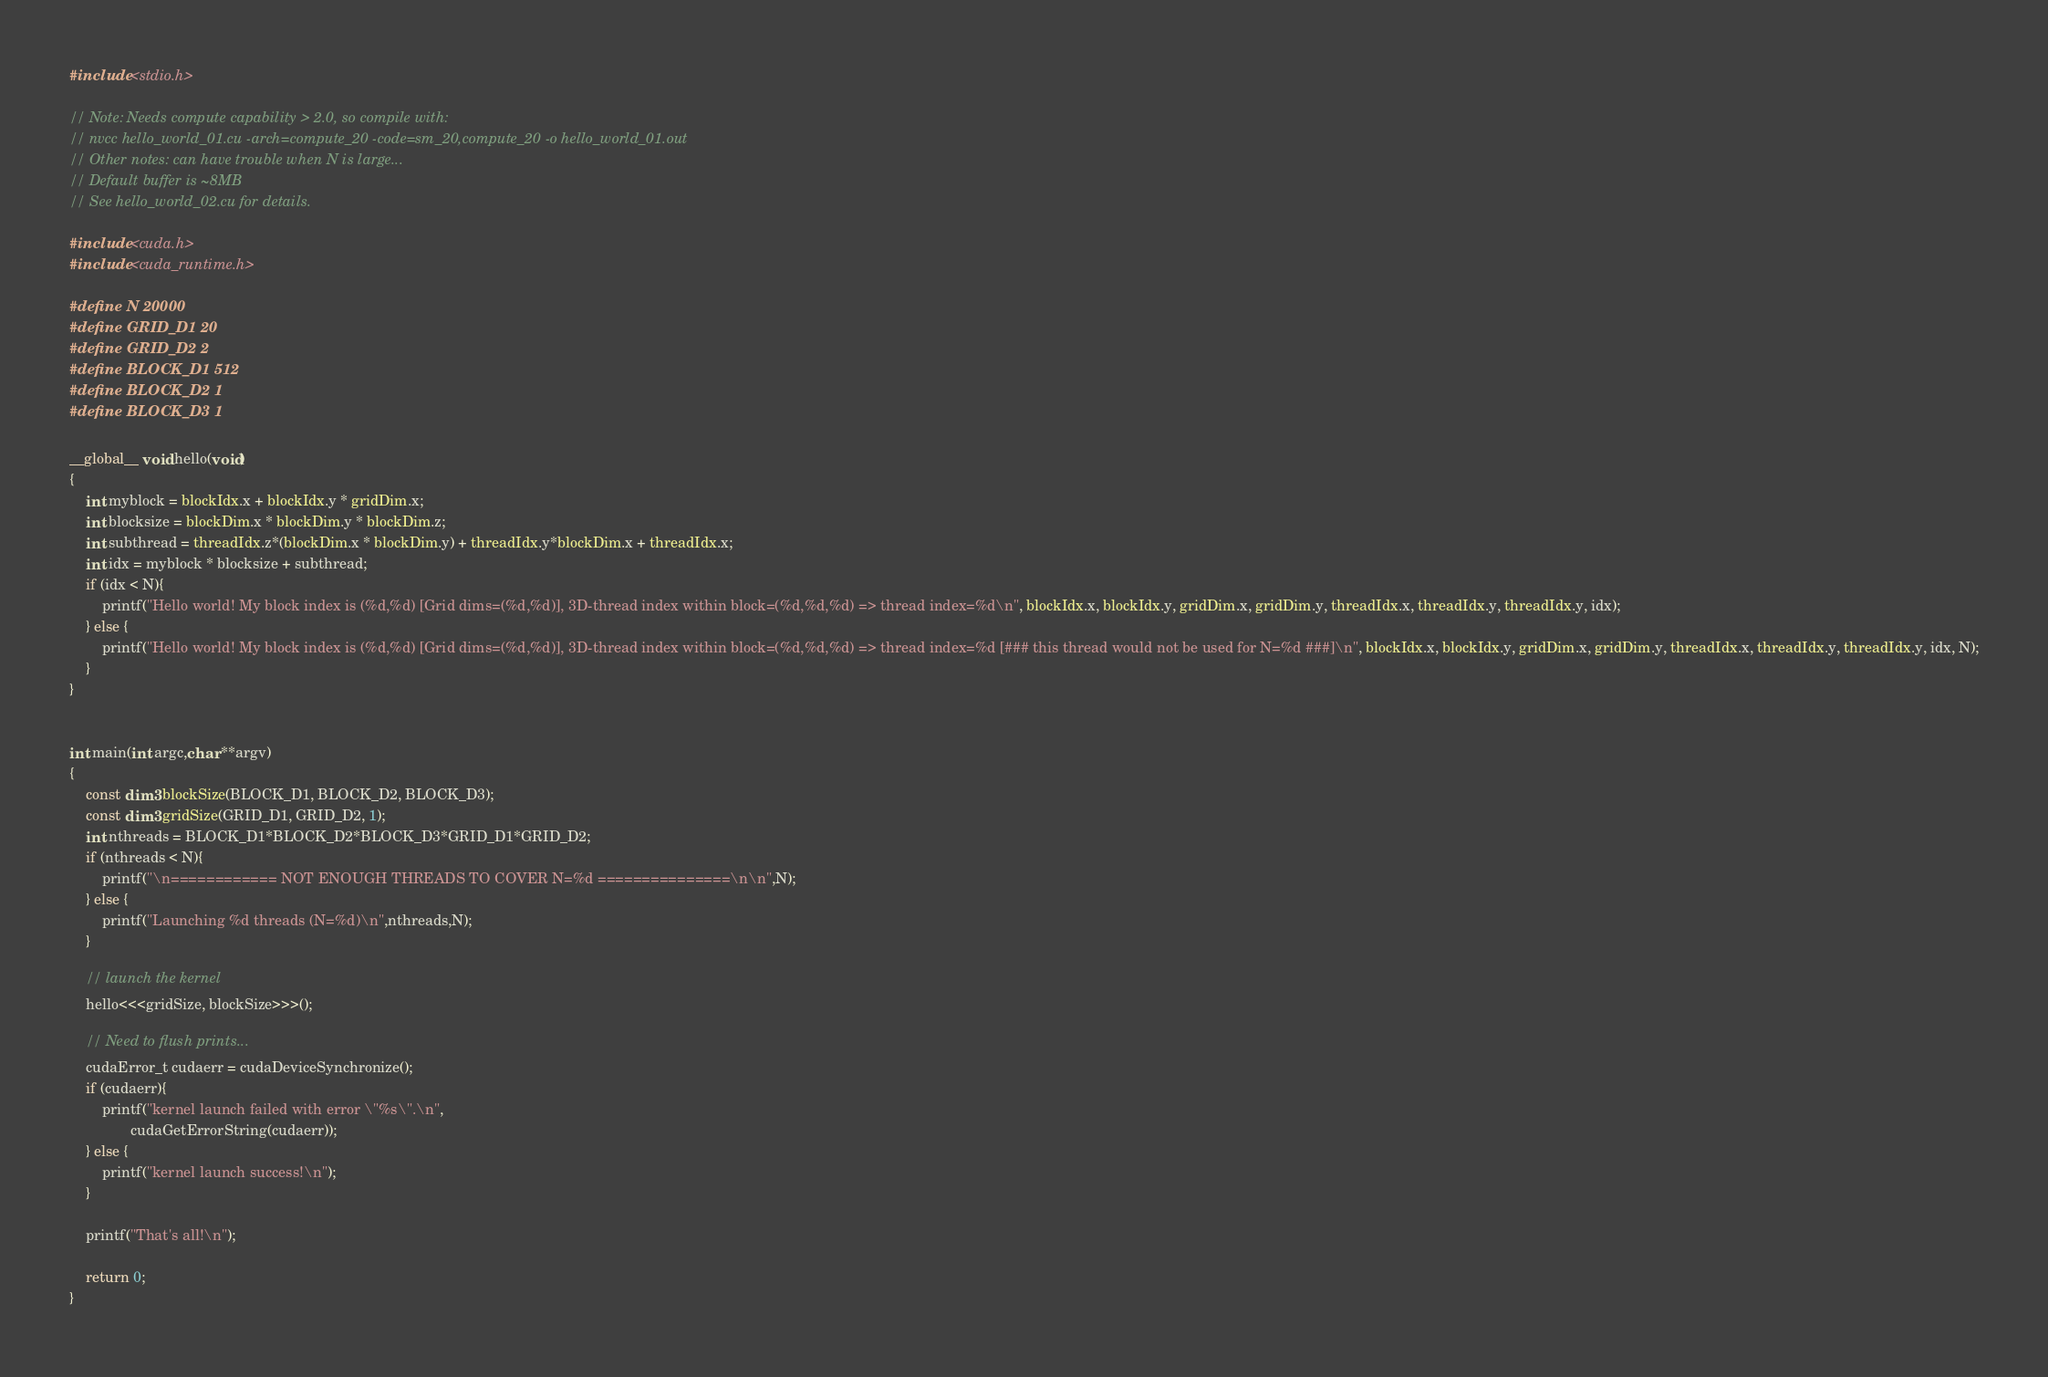Convert code to text. <code><loc_0><loc_0><loc_500><loc_500><_Cuda_>#include <stdio.h>

// Note: Needs compute capability > 2.0, so compile with:
// nvcc hello_world_01.cu -arch=compute_20 -code=sm_20,compute_20 -o hello_world_01.out
// Other notes: can have trouble when N is large...
// Default buffer is ~8MB
// See hello_world_02.cu for details.

#include <cuda.h>
#include <cuda_runtime.h>

#define N 20000
#define GRID_D1 20
#define GRID_D2 2
#define BLOCK_D1 512
#define BLOCK_D2 1
#define BLOCK_D3 1

__global__ void hello(void)
{
    int myblock = blockIdx.x + blockIdx.y * gridDim.x;
    int blocksize = blockDim.x * blockDim.y * blockDim.z;
    int subthread = threadIdx.z*(blockDim.x * blockDim.y) + threadIdx.y*blockDim.x + threadIdx.x;
    int idx = myblock * blocksize + subthread;
    if (idx < N){  
        printf("Hello world! My block index is (%d,%d) [Grid dims=(%d,%d)], 3D-thread index within block=(%d,%d,%d) => thread index=%d\n", blockIdx.x, blockIdx.y, gridDim.x, gridDim.y, threadIdx.x, threadIdx.y, threadIdx.y, idx);
    } else {
        printf("Hello world! My block index is (%d,%d) [Grid dims=(%d,%d)], 3D-thread index within block=(%d,%d,%d) => thread index=%d [### this thread would not be used for N=%d ###]\n", blockIdx.x, blockIdx.y, gridDim.x, gridDim.y, threadIdx.x, threadIdx.y, threadIdx.y, idx, N);
    }
}


int main(int argc,char **argv)
{
    const dim3 blockSize(BLOCK_D1, BLOCK_D2, BLOCK_D3);
    const dim3 gridSize(GRID_D1, GRID_D2, 1);
    int nthreads = BLOCK_D1*BLOCK_D2*BLOCK_D3*GRID_D1*GRID_D2;
    if (nthreads < N){
        printf("\n============ NOT ENOUGH THREADS TO COVER N=%d ===============\n\n",N);
    } else {
        printf("Launching %d threads (N=%d)\n",nthreads,N);
    }
    
    // launch the kernel
    hello<<<gridSize, blockSize>>>();
    
    // Need to flush prints...
    cudaError_t cudaerr = cudaDeviceSynchronize();
    if (cudaerr){
        printf("kernel launch failed with error \"%s\".\n",
               cudaGetErrorString(cudaerr));
    } else {
        printf("kernel launch success!\n");
    }
    
    printf("That's all!\n");

    return 0;
}




</code> 